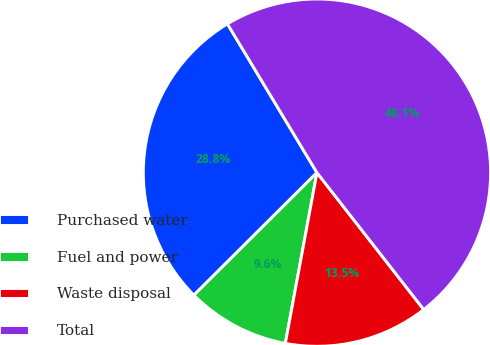Convert chart. <chart><loc_0><loc_0><loc_500><loc_500><pie_chart><fcel>Purchased water<fcel>Fuel and power<fcel>Waste disposal<fcel>Total<nl><fcel>28.85%<fcel>9.62%<fcel>13.46%<fcel>48.08%<nl></chart> 